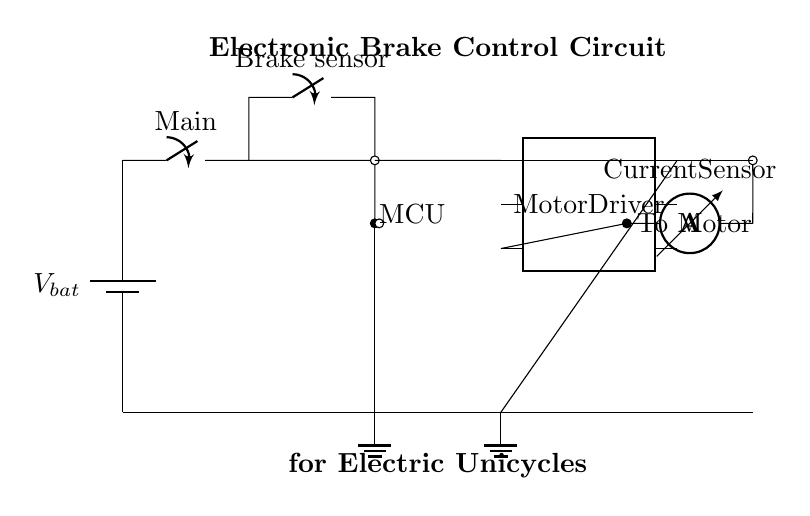What is the main power source for this circuit? The main power source is denoted as V_bat, which is the battery supplying voltage to the circuit.
Answer: V_bat What component realizes the braking function in this circuit? The braking function is enabled by the Brake sensor, which detects the braking action and communicates it to the microcontroller.
Answer: Brake sensor Which component acts as the brain of this electronic brake control circuit? The microcontroller is labeled as MCU and is responsible for processing input from the brake sensor and controlling other components accordingly.
Answer: MCU How many pins does the motor driver have? The motor driver component is shown as a dip chip with six pins.
Answer: Six pins What is the role of the current sensor in this circuit? The current sensor monitors the current flowing to the motor and provides feedback to ensure proper functioning, especially during braking scenarios.
Answer: Monitors current If the brake sensor is activated, what component receives this signal first? The brake sensor sends its signal directly to the microcontroller (MCU), which is the first component to receive and process the signal when braking occurs.
Answer: MCU What termination is used for the signals in this circuit? The circuit uses short connections for signals, indicated by lines without components, directing the flow between various terminals in the circuit.
Answer: Short connections 